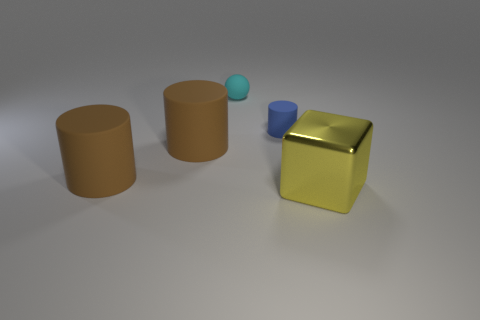The tiny object that is the same material as the tiny cyan sphere is what color? blue 